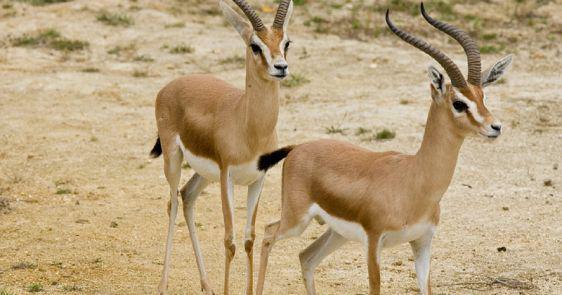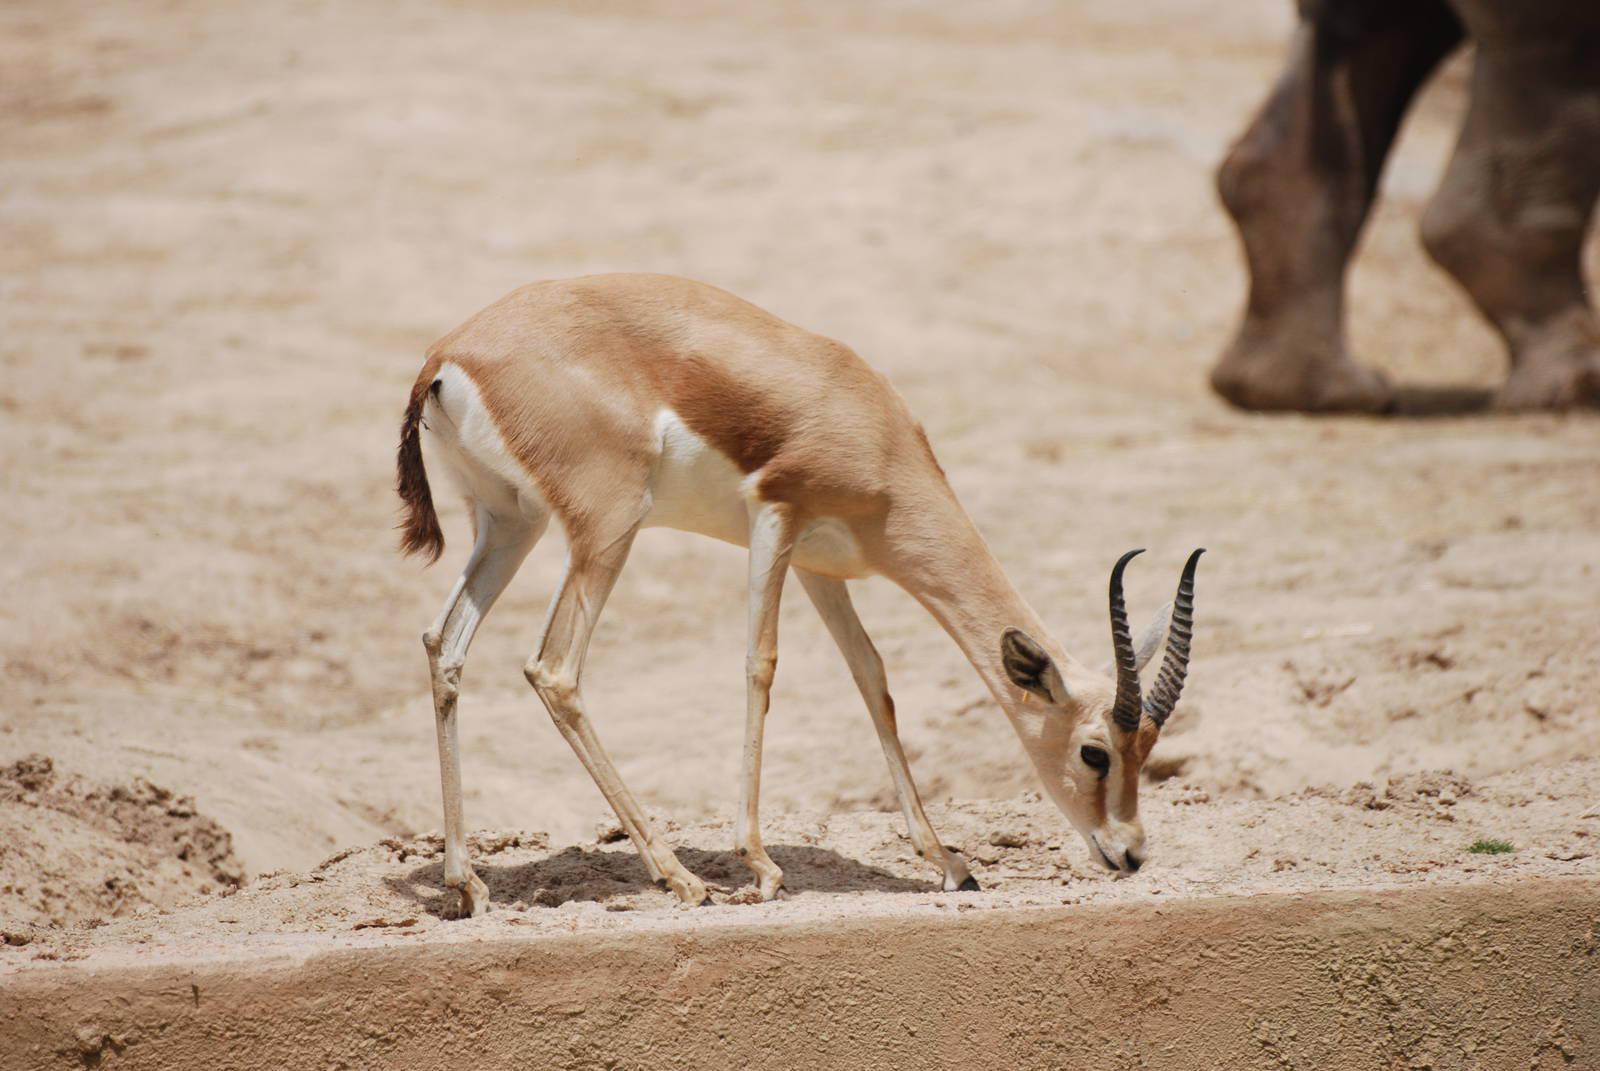The first image is the image on the left, the second image is the image on the right. Examine the images to the left and right. Is the description "There are two animals in total." accurate? Answer yes or no. No. 